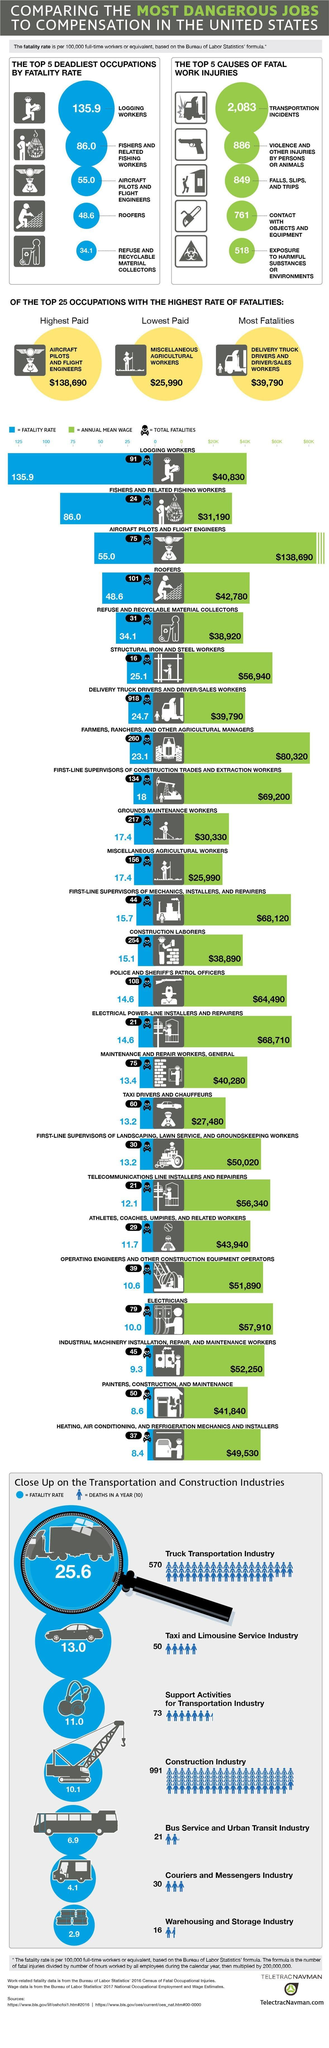Identify some key points in this picture. The occupation that had the highest total fatalities was that of delivery truck drivers and driver/sales workers. Aircraft pilots and flight engineers are the third deadliest occupation, according to recent studies. The maximum number of deaths in the Taxi and Limousine Service Industry is 50. The total fatality rate of grounds maintenance workers is 217 per 100,000 workers. The lowest paid group earns a wage of $25,990. 